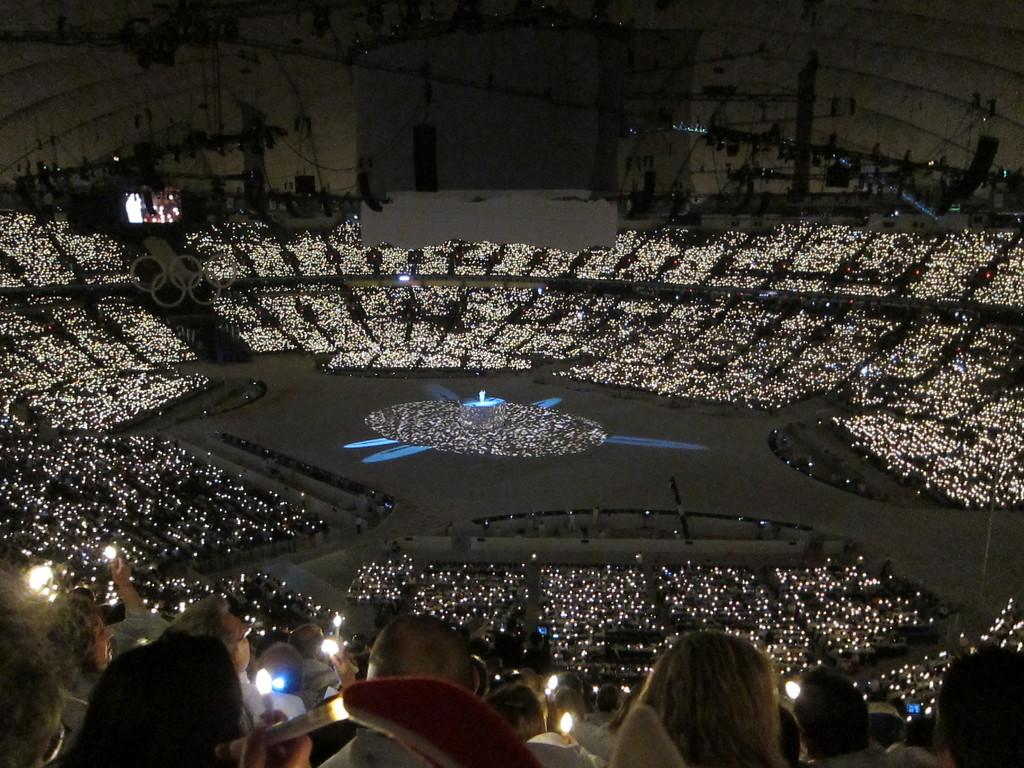What is the main subject of the image? The main subject of the image is a crowd in a stadium. What can be seen in the background of the image? There are lights visible in the background. Are there any lights at the bottom of the image? Yes, there are lights at the bottom of the image. What else can be seen at the bottom of the image? There are persons visible at the bottom of the image. What type of shirt is the dog wearing in the image? There is no dog or shirt present in the image. How many bears are visible in the image? There are no bears present in the image. 